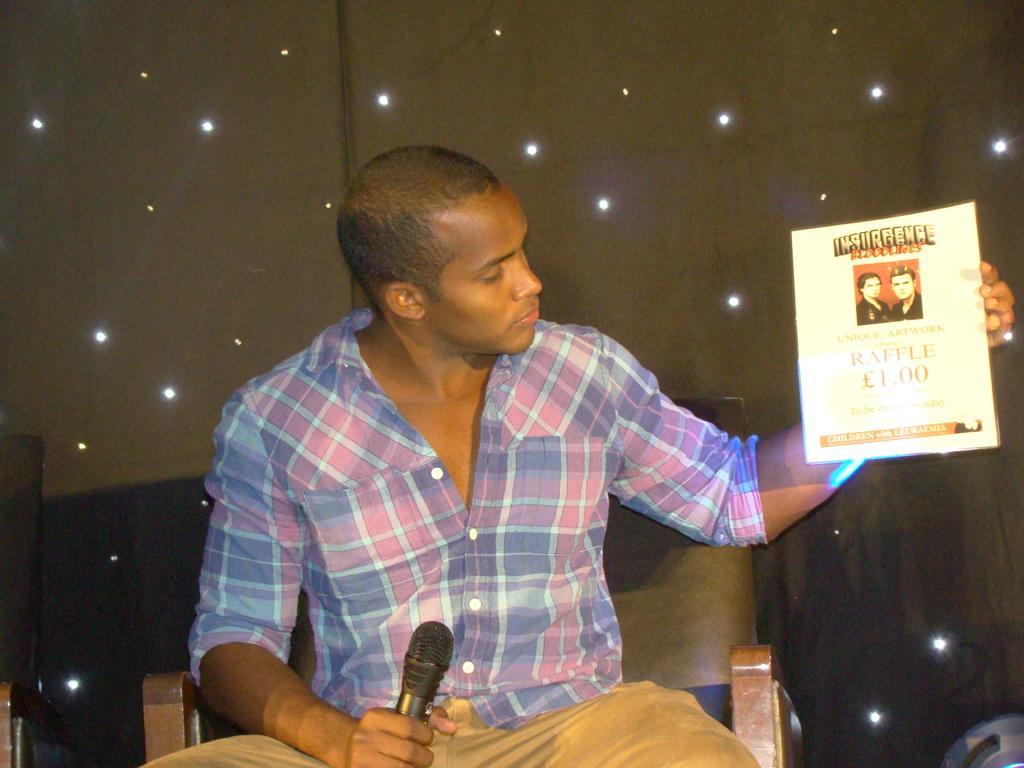Could you give a brief overview of what you see in this image? In this picture I can see there is a man sitting here and he is holding a micro phone in his right hand and a card board in his left hand and in the backdrop I can see there is a black wall with some lights. 